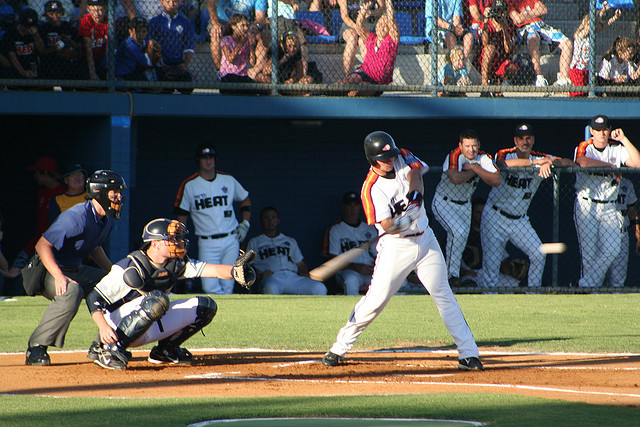Identify the text displayed in this image. HEAT HEAT HEAT 